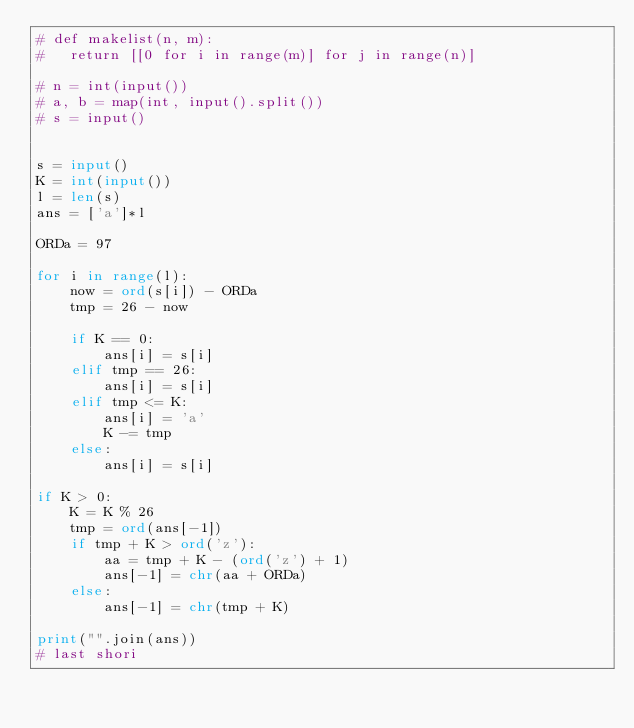Convert code to text. <code><loc_0><loc_0><loc_500><loc_500><_Python_># def makelist(n, m):
# 	return [[0 for i in range(m)] for j in range(n)]

# n = int(input())
# a, b = map(int, input().split())
# s = input()


s = input()
K = int(input())
l = len(s)
ans = ['a']*l

ORDa = 97

for i in range(l):
	now = ord(s[i]) - ORDa
	tmp = 26 - now
	
	if K == 0:
		ans[i] = s[i]
	elif tmp == 26:
		ans[i] = s[i]
	elif tmp <= K:
		ans[i] = 'a'
		K -= tmp
	else:
		ans[i] = s[i]

if K > 0:
	K = K % 26
	tmp = ord(ans[-1])
	if tmp + K > ord('z'):
		aa = tmp + K - (ord('z') + 1)
		ans[-1] = chr(aa + ORDa)
	else:
		ans[-1] = chr(tmp + K)
		
print("".join(ans))
# last shori
</code> 